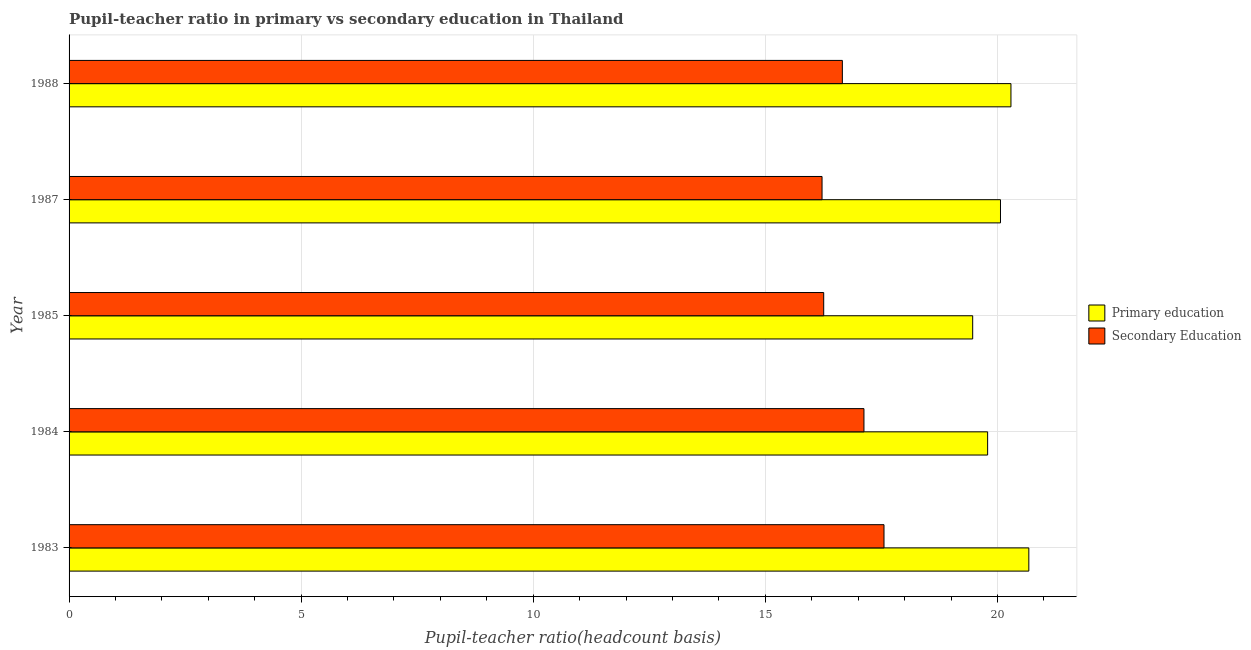Are the number of bars on each tick of the Y-axis equal?
Make the answer very short. Yes. What is the label of the 1st group of bars from the top?
Give a very brief answer. 1988. In how many cases, is the number of bars for a given year not equal to the number of legend labels?
Your answer should be very brief. 0. What is the pupil teacher ratio on secondary education in 1985?
Keep it short and to the point. 16.26. Across all years, what is the maximum pupil-teacher ratio in primary education?
Provide a short and direct response. 20.68. Across all years, what is the minimum pupil-teacher ratio in primary education?
Provide a short and direct response. 19.47. What is the total pupil-teacher ratio in primary education in the graph?
Keep it short and to the point. 100.29. What is the difference between the pupil teacher ratio on secondary education in 1983 and that in 1984?
Offer a terse response. 0.43. What is the difference between the pupil teacher ratio on secondary education in 1987 and the pupil-teacher ratio in primary education in 1985?
Your answer should be very brief. -3.25. What is the average pupil teacher ratio on secondary education per year?
Your answer should be compact. 16.76. In the year 1985, what is the difference between the pupil teacher ratio on secondary education and pupil-teacher ratio in primary education?
Your response must be concise. -3.21. In how many years, is the pupil teacher ratio on secondary education greater than 2 ?
Your answer should be compact. 5. What is the ratio of the pupil-teacher ratio in primary education in 1983 to that in 1985?
Give a very brief answer. 1.06. Is the pupil teacher ratio on secondary education in 1987 less than that in 1988?
Provide a short and direct response. Yes. Is the difference between the pupil teacher ratio on secondary education in 1984 and 1985 greater than the difference between the pupil-teacher ratio in primary education in 1984 and 1985?
Your response must be concise. Yes. What is the difference between the highest and the second highest pupil-teacher ratio in primary education?
Provide a short and direct response. 0.39. What is the difference between the highest and the lowest pupil-teacher ratio in primary education?
Your response must be concise. 1.21. In how many years, is the pupil teacher ratio on secondary education greater than the average pupil teacher ratio on secondary education taken over all years?
Ensure brevity in your answer.  2. What does the 1st bar from the top in 1983 represents?
Your answer should be very brief. Secondary Education. How many bars are there?
Provide a short and direct response. 10. How many years are there in the graph?
Provide a short and direct response. 5. What is the difference between two consecutive major ticks on the X-axis?
Your response must be concise. 5. Are the values on the major ticks of X-axis written in scientific E-notation?
Make the answer very short. No. Does the graph contain any zero values?
Keep it short and to the point. No. Where does the legend appear in the graph?
Give a very brief answer. Center right. How many legend labels are there?
Your answer should be compact. 2. What is the title of the graph?
Your answer should be very brief. Pupil-teacher ratio in primary vs secondary education in Thailand. Does "Taxes" appear as one of the legend labels in the graph?
Offer a terse response. No. What is the label or title of the X-axis?
Your answer should be very brief. Pupil-teacher ratio(headcount basis). What is the label or title of the Y-axis?
Keep it short and to the point. Year. What is the Pupil-teacher ratio(headcount basis) in Primary education in 1983?
Provide a succinct answer. 20.68. What is the Pupil-teacher ratio(headcount basis) in Secondary Education in 1983?
Keep it short and to the point. 17.56. What is the Pupil-teacher ratio(headcount basis) in Primary education in 1984?
Give a very brief answer. 19.79. What is the Pupil-teacher ratio(headcount basis) in Secondary Education in 1984?
Your answer should be compact. 17.12. What is the Pupil-teacher ratio(headcount basis) in Primary education in 1985?
Provide a short and direct response. 19.47. What is the Pupil-teacher ratio(headcount basis) of Secondary Education in 1985?
Provide a succinct answer. 16.26. What is the Pupil-teacher ratio(headcount basis) of Primary education in 1987?
Provide a short and direct response. 20.07. What is the Pupil-teacher ratio(headcount basis) of Secondary Education in 1987?
Your answer should be compact. 16.22. What is the Pupil-teacher ratio(headcount basis) in Primary education in 1988?
Give a very brief answer. 20.29. What is the Pupil-teacher ratio(headcount basis) in Secondary Education in 1988?
Keep it short and to the point. 16.66. Across all years, what is the maximum Pupil-teacher ratio(headcount basis) in Primary education?
Your response must be concise. 20.68. Across all years, what is the maximum Pupil-teacher ratio(headcount basis) in Secondary Education?
Ensure brevity in your answer.  17.56. Across all years, what is the minimum Pupil-teacher ratio(headcount basis) of Primary education?
Make the answer very short. 19.47. Across all years, what is the minimum Pupil-teacher ratio(headcount basis) in Secondary Education?
Provide a short and direct response. 16.22. What is the total Pupil-teacher ratio(headcount basis) in Primary education in the graph?
Make the answer very short. 100.29. What is the total Pupil-teacher ratio(headcount basis) in Secondary Education in the graph?
Your response must be concise. 83.82. What is the difference between the Pupil-teacher ratio(headcount basis) in Primary education in 1983 and that in 1984?
Offer a terse response. 0.89. What is the difference between the Pupil-teacher ratio(headcount basis) in Secondary Education in 1983 and that in 1984?
Offer a very short reply. 0.43. What is the difference between the Pupil-teacher ratio(headcount basis) in Primary education in 1983 and that in 1985?
Your answer should be compact. 1.21. What is the difference between the Pupil-teacher ratio(headcount basis) of Secondary Education in 1983 and that in 1985?
Make the answer very short. 1.3. What is the difference between the Pupil-teacher ratio(headcount basis) in Primary education in 1983 and that in 1987?
Ensure brevity in your answer.  0.61. What is the difference between the Pupil-teacher ratio(headcount basis) of Secondary Education in 1983 and that in 1987?
Your answer should be compact. 1.33. What is the difference between the Pupil-teacher ratio(headcount basis) in Primary education in 1983 and that in 1988?
Keep it short and to the point. 0.39. What is the difference between the Pupil-teacher ratio(headcount basis) of Secondary Education in 1983 and that in 1988?
Provide a succinct answer. 0.9. What is the difference between the Pupil-teacher ratio(headcount basis) of Primary education in 1984 and that in 1985?
Make the answer very short. 0.32. What is the difference between the Pupil-teacher ratio(headcount basis) of Secondary Education in 1984 and that in 1985?
Your response must be concise. 0.87. What is the difference between the Pupil-teacher ratio(headcount basis) of Primary education in 1984 and that in 1987?
Your answer should be compact. -0.28. What is the difference between the Pupil-teacher ratio(headcount basis) in Secondary Education in 1984 and that in 1987?
Your answer should be compact. 0.9. What is the difference between the Pupil-teacher ratio(headcount basis) in Primary education in 1984 and that in 1988?
Keep it short and to the point. -0.5. What is the difference between the Pupil-teacher ratio(headcount basis) of Secondary Education in 1984 and that in 1988?
Your response must be concise. 0.47. What is the difference between the Pupil-teacher ratio(headcount basis) of Primary education in 1985 and that in 1987?
Make the answer very short. -0.6. What is the difference between the Pupil-teacher ratio(headcount basis) of Secondary Education in 1985 and that in 1987?
Provide a short and direct response. 0.04. What is the difference between the Pupil-teacher ratio(headcount basis) of Primary education in 1985 and that in 1988?
Your answer should be very brief. -0.82. What is the difference between the Pupil-teacher ratio(headcount basis) of Secondary Education in 1985 and that in 1988?
Your response must be concise. -0.4. What is the difference between the Pupil-teacher ratio(headcount basis) of Primary education in 1987 and that in 1988?
Your answer should be compact. -0.23. What is the difference between the Pupil-teacher ratio(headcount basis) of Secondary Education in 1987 and that in 1988?
Make the answer very short. -0.44. What is the difference between the Pupil-teacher ratio(headcount basis) in Primary education in 1983 and the Pupil-teacher ratio(headcount basis) in Secondary Education in 1984?
Ensure brevity in your answer.  3.55. What is the difference between the Pupil-teacher ratio(headcount basis) of Primary education in 1983 and the Pupil-teacher ratio(headcount basis) of Secondary Education in 1985?
Your answer should be very brief. 4.42. What is the difference between the Pupil-teacher ratio(headcount basis) of Primary education in 1983 and the Pupil-teacher ratio(headcount basis) of Secondary Education in 1987?
Provide a succinct answer. 4.45. What is the difference between the Pupil-teacher ratio(headcount basis) of Primary education in 1983 and the Pupil-teacher ratio(headcount basis) of Secondary Education in 1988?
Give a very brief answer. 4.02. What is the difference between the Pupil-teacher ratio(headcount basis) of Primary education in 1984 and the Pupil-teacher ratio(headcount basis) of Secondary Education in 1985?
Provide a succinct answer. 3.53. What is the difference between the Pupil-teacher ratio(headcount basis) in Primary education in 1984 and the Pupil-teacher ratio(headcount basis) in Secondary Education in 1987?
Offer a terse response. 3.57. What is the difference between the Pupil-teacher ratio(headcount basis) in Primary education in 1984 and the Pupil-teacher ratio(headcount basis) in Secondary Education in 1988?
Provide a succinct answer. 3.13. What is the difference between the Pupil-teacher ratio(headcount basis) of Primary education in 1985 and the Pupil-teacher ratio(headcount basis) of Secondary Education in 1987?
Provide a succinct answer. 3.25. What is the difference between the Pupil-teacher ratio(headcount basis) of Primary education in 1985 and the Pupil-teacher ratio(headcount basis) of Secondary Education in 1988?
Keep it short and to the point. 2.81. What is the difference between the Pupil-teacher ratio(headcount basis) in Primary education in 1987 and the Pupil-teacher ratio(headcount basis) in Secondary Education in 1988?
Keep it short and to the point. 3.41. What is the average Pupil-teacher ratio(headcount basis) in Primary education per year?
Offer a very short reply. 20.06. What is the average Pupil-teacher ratio(headcount basis) of Secondary Education per year?
Provide a short and direct response. 16.76. In the year 1983, what is the difference between the Pupil-teacher ratio(headcount basis) of Primary education and Pupil-teacher ratio(headcount basis) of Secondary Education?
Ensure brevity in your answer.  3.12. In the year 1984, what is the difference between the Pupil-teacher ratio(headcount basis) of Primary education and Pupil-teacher ratio(headcount basis) of Secondary Education?
Make the answer very short. 2.66. In the year 1985, what is the difference between the Pupil-teacher ratio(headcount basis) of Primary education and Pupil-teacher ratio(headcount basis) of Secondary Education?
Your response must be concise. 3.21. In the year 1987, what is the difference between the Pupil-teacher ratio(headcount basis) of Primary education and Pupil-teacher ratio(headcount basis) of Secondary Education?
Provide a succinct answer. 3.84. In the year 1988, what is the difference between the Pupil-teacher ratio(headcount basis) in Primary education and Pupil-teacher ratio(headcount basis) in Secondary Education?
Offer a very short reply. 3.63. What is the ratio of the Pupil-teacher ratio(headcount basis) of Primary education in 1983 to that in 1984?
Ensure brevity in your answer.  1.04. What is the ratio of the Pupil-teacher ratio(headcount basis) in Secondary Education in 1983 to that in 1984?
Offer a very short reply. 1.03. What is the ratio of the Pupil-teacher ratio(headcount basis) in Primary education in 1983 to that in 1985?
Give a very brief answer. 1.06. What is the ratio of the Pupil-teacher ratio(headcount basis) of Secondary Education in 1983 to that in 1985?
Offer a terse response. 1.08. What is the ratio of the Pupil-teacher ratio(headcount basis) of Primary education in 1983 to that in 1987?
Ensure brevity in your answer.  1.03. What is the ratio of the Pupil-teacher ratio(headcount basis) of Secondary Education in 1983 to that in 1987?
Provide a succinct answer. 1.08. What is the ratio of the Pupil-teacher ratio(headcount basis) of Primary education in 1983 to that in 1988?
Your response must be concise. 1.02. What is the ratio of the Pupil-teacher ratio(headcount basis) of Secondary Education in 1983 to that in 1988?
Offer a very short reply. 1.05. What is the ratio of the Pupil-teacher ratio(headcount basis) of Primary education in 1984 to that in 1985?
Make the answer very short. 1.02. What is the ratio of the Pupil-teacher ratio(headcount basis) in Secondary Education in 1984 to that in 1985?
Ensure brevity in your answer.  1.05. What is the ratio of the Pupil-teacher ratio(headcount basis) of Primary education in 1984 to that in 1987?
Ensure brevity in your answer.  0.99. What is the ratio of the Pupil-teacher ratio(headcount basis) in Secondary Education in 1984 to that in 1987?
Your response must be concise. 1.06. What is the ratio of the Pupil-teacher ratio(headcount basis) in Primary education in 1984 to that in 1988?
Your answer should be very brief. 0.98. What is the ratio of the Pupil-teacher ratio(headcount basis) in Secondary Education in 1984 to that in 1988?
Offer a very short reply. 1.03. What is the ratio of the Pupil-teacher ratio(headcount basis) of Primary education in 1985 to that in 1987?
Your answer should be compact. 0.97. What is the ratio of the Pupil-teacher ratio(headcount basis) of Secondary Education in 1985 to that in 1987?
Keep it short and to the point. 1. What is the ratio of the Pupil-teacher ratio(headcount basis) of Primary education in 1985 to that in 1988?
Your answer should be very brief. 0.96. What is the ratio of the Pupil-teacher ratio(headcount basis) in Secondary Education in 1985 to that in 1988?
Make the answer very short. 0.98. What is the ratio of the Pupil-teacher ratio(headcount basis) of Primary education in 1987 to that in 1988?
Keep it short and to the point. 0.99. What is the ratio of the Pupil-teacher ratio(headcount basis) in Secondary Education in 1987 to that in 1988?
Ensure brevity in your answer.  0.97. What is the difference between the highest and the second highest Pupil-teacher ratio(headcount basis) in Primary education?
Ensure brevity in your answer.  0.39. What is the difference between the highest and the second highest Pupil-teacher ratio(headcount basis) of Secondary Education?
Ensure brevity in your answer.  0.43. What is the difference between the highest and the lowest Pupil-teacher ratio(headcount basis) in Primary education?
Offer a terse response. 1.21. What is the difference between the highest and the lowest Pupil-teacher ratio(headcount basis) in Secondary Education?
Make the answer very short. 1.33. 